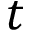Convert formula to latex. <formula><loc_0><loc_0><loc_500><loc_500>t</formula> 